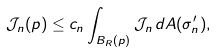<formula> <loc_0><loc_0><loc_500><loc_500>\mathcal { J } _ { n } ( p ) \leq c _ { n } \int _ { B _ { R } ( p ) } \mathcal { J } _ { n } \, d A ( \sigma ^ { \prime } _ { n } ) ,</formula> 